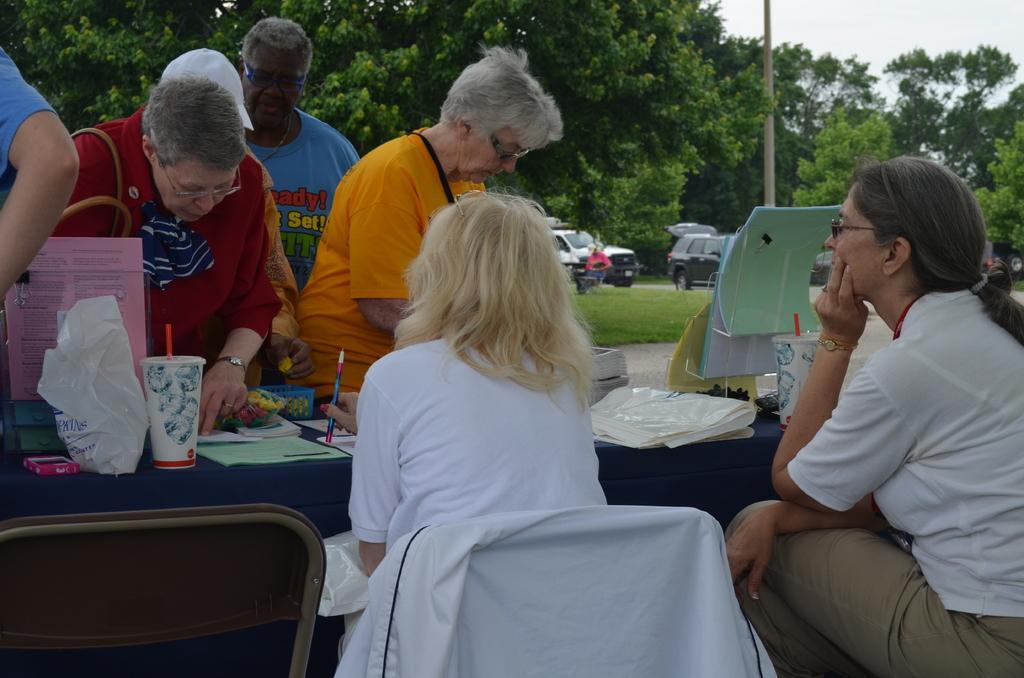Describe this image in one or two sentences. At the top we can see sky. These are trees. This is a fresh green grass. We can see vehicles on the road. We can see two women sitting on chairs in front of a table and on the table we can see glasses, polythene cover, files. We can see persons standing near to the table. 